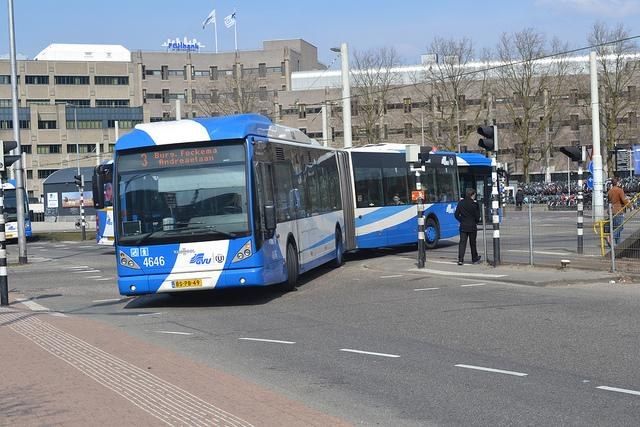What style design connects the two bus parts here? Please explain your reasoning. accordion. Two buses are connected by a section in the middle. 